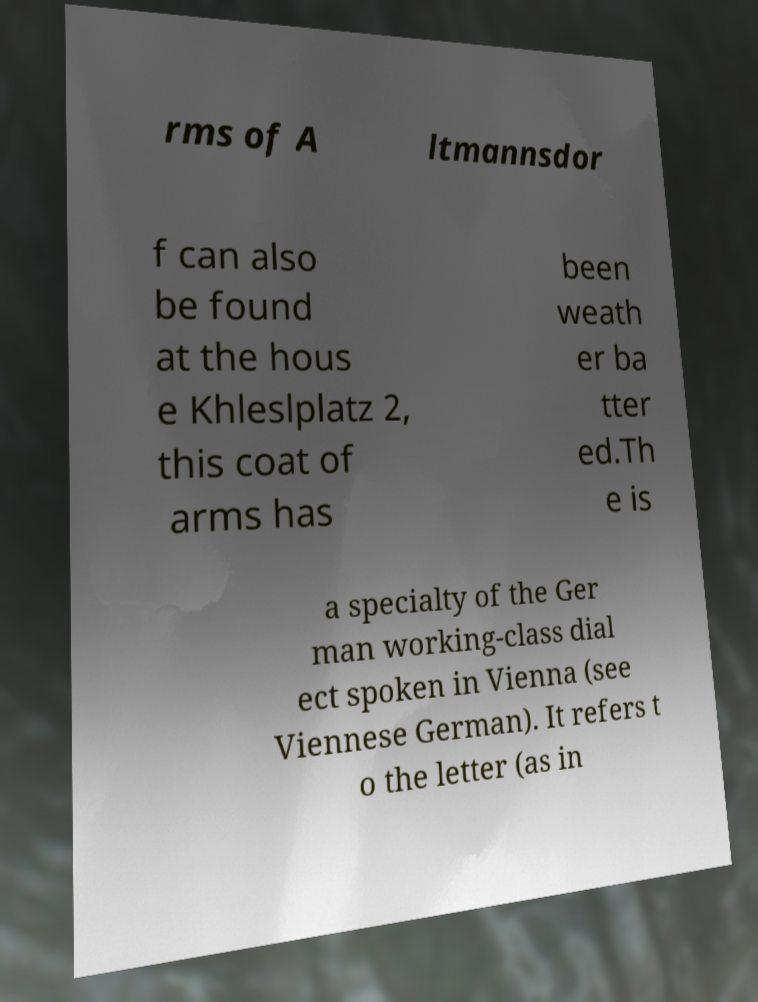Please read and relay the text visible in this image. What does it say? rms of A ltmannsdor f can also be found at the hous e Khleslplatz 2, this coat of arms has been weath er ba tter ed.Th e is a specialty of the Ger man working-class dial ect spoken in Vienna (see Viennese German). It refers t o the letter (as in 